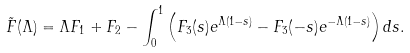Convert formula to latex. <formula><loc_0><loc_0><loc_500><loc_500>\tilde { F } ( \Lambda ) = \Lambda F _ { 1 } + F _ { 2 } - \int _ { 0 } ^ { 1 } \left ( F _ { 3 } ( s ) e ^ { \Lambda ( 1 - s ) } - F _ { 3 } ( - s ) e ^ { - \Lambda ( 1 - s ) } \right ) d s .</formula> 